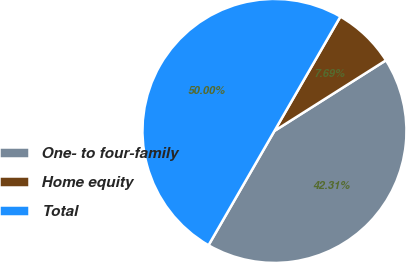<chart> <loc_0><loc_0><loc_500><loc_500><pie_chart><fcel>One- to four-family<fcel>Home equity<fcel>Total<nl><fcel>42.31%<fcel>7.69%<fcel>50.0%<nl></chart> 